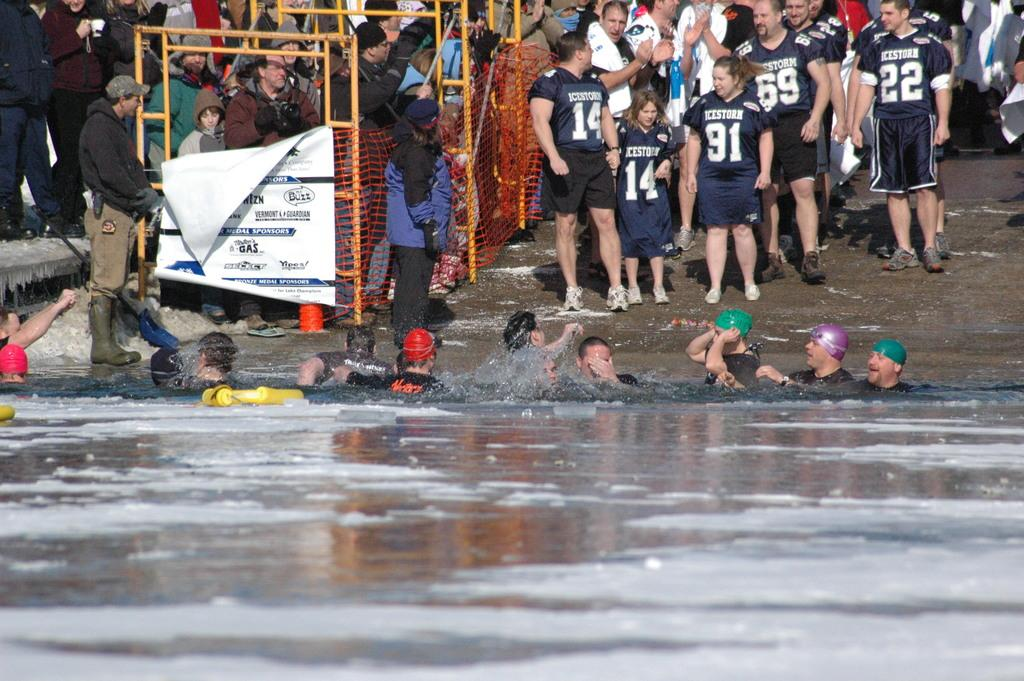What are the people in the image doing? There are people in the water, and some people are visible at the top of the image. What objects can be seen in the image? Rods, nets, and a banner are visible in the image. What might the people be holding? Some people are holding objects, which could be the rods or nets. What type of plant is growing near the people in the image? There is no plant visible in the image; it features people in the water and at the top of the image, along with rods, nets, and a banner. Can you tell me where the mom is in the image? There is no mention of a mom or any specific person in the image; it simply shows people in the water and at the top of the image, along with rods, nets, and a banner. 